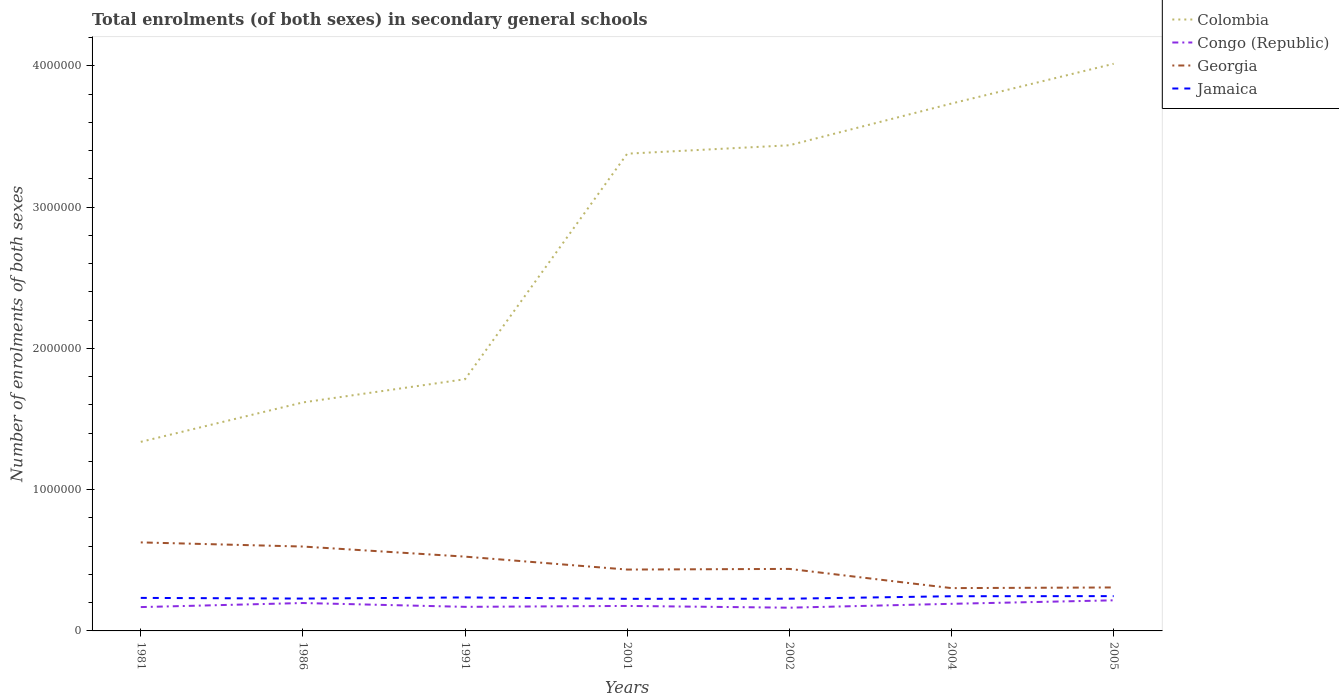Does the line corresponding to Congo (Republic) intersect with the line corresponding to Colombia?
Give a very brief answer. No. Across all years, what is the maximum number of enrolments in secondary schools in Colombia?
Your answer should be compact. 1.34e+06. What is the total number of enrolments in secondary schools in Congo (Republic) in the graph?
Keep it short and to the point. 4215. What is the difference between the highest and the second highest number of enrolments in secondary schools in Georgia?
Keep it short and to the point. 3.24e+05. How many lines are there?
Offer a very short reply. 4. What is the difference between two consecutive major ticks on the Y-axis?
Give a very brief answer. 1.00e+06. Are the values on the major ticks of Y-axis written in scientific E-notation?
Provide a short and direct response. No. Does the graph contain any zero values?
Ensure brevity in your answer.  No. Where does the legend appear in the graph?
Your answer should be compact. Top right. What is the title of the graph?
Provide a short and direct response. Total enrolments (of both sexes) in secondary general schools. What is the label or title of the X-axis?
Keep it short and to the point. Years. What is the label or title of the Y-axis?
Provide a short and direct response. Number of enrolments of both sexes. What is the Number of enrolments of both sexes in Colombia in 1981?
Offer a terse response. 1.34e+06. What is the Number of enrolments of both sexes in Congo (Republic) in 1981?
Your answer should be compact. 1.69e+05. What is the Number of enrolments of both sexes in Georgia in 1981?
Your response must be concise. 6.27e+05. What is the Number of enrolments of both sexes in Jamaica in 1981?
Provide a short and direct response. 2.34e+05. What is the Number of enrolments of both sexes of Colombia in 1986?
Offer a very short reply. 1.62e+06. What is the Number of enrolments of both sexes of Congo (Republic) in 1986?
Provide a short and direct response. 1.97e+05. What is the Number of enrolments of both sexes of Georgia in 1986?
Make the answer very short. 5.97e+05. What is the Number of enrolments of both sexes in Jamaica in 1986?
Offer a very short reply. 2.29e+05. What is the Number of enrolments of both sexes of Colombia in 1991?
Your response must be concise. 1.78e+06. What is the Number of enrolments of both sexes of Congo (Republic) in 1991?
Make the answer very short. 1.70e+05. What is the Number of enrolments of both sexes of Georgia in 1991?
Your answer should be very brief. 5.26e+05. What is the Number of enrolments of both sexes in Jamaica in 1991?
Your response must be concise. 2.37e+05. What is the Number of enrolments of both sexes in Colombia in 2001?
Provide a short and direct response. 3.38e+06. What is the Number of enrolments of both sexes of Congo (Republic) in 2001?
Your response must be concise. 1.77e+05. What is the Number of enrolments of both sexes of Georgia in 2001?
Offer a very short reply. 4.34e+05. What is the Number of enrolments of both sexes of Jamaica in 2001?
Provide a short and direct response. 2.27e+05. What is the Number of enrolments of both sexes in Colombia in 2002?
Keep it short and to the point. 3.44e+06. What is the Number of enrolments of both sexes in Congo (Republic) in 2002?
Provide a short and direct response. 1.65e+05. What is the Number of enrolments of both sexes of Georgia in 2002?
Keep it short and to the point. 4.39e+05. What is the Number of enrolments of both sexes in Jamaica in 2002?
Offer a very short reply. 2.28e+05. What is the Number of enrolments of both sexes in Colombia in 2004?
Provide a succinct answer. 3.73e+06. What is the Number of enrolments of both sexes in Congo (Republic) in 2004?
Offer a terse response. 1.92e+05. What is the Number of enrolments of both sexes in Georgia in 2004?
Offer a terse response. 3.03e+05. What is the Number of enrolments of both sexes in Jamaica in 2004?
Provide a succinct answer. 2.46e+05. What is the Number of enrolments of both sexes in Colombia in 2005?
Your answer should be very brief. 4.01e+06. What is the Number of enrolments of both sexes in Congo (Republic) in 2005?
Give a very brief answer. 2.17e+05. What is the Number of enrolments of both sexes in Georgia in 2005?
Make the answer very short. 3.08e+05. What is the Number of enrolments of both sexes in Jamaica in 2005?
Provide a succinct answer. 2.46e+05. Across all years, what is the maximum Number of enrolments of both sexes of Colombia?
Your answer should be very brief. 4.01e+06. Across all years, what is the maximum Number of enrolments of both sexes in Congo (Republic)?
Keep it short and to the point. 2.17e+05. Across all years, what is the maximum Number of enrolments of both sexes in Georgia?
Your answer should be very brief. 6.27e+05. Across all years, what is the maximum Number of enrolments of both sexes in Jamaica?
Your answer should be very brief. 2.46e+05. Across all years, what is the minimum Number of enrolments of both sexes of Colombia?
Your answer should be compact. 1.34e+06. Across all years, what is the minimum Number of enrolments of both sexes in Congo (Republic)?
Make the answer very short. 1.65e+05. Across all years, what is the minimum Number of enrolments of both sexes in Georgia?
Give a very brief answer. 3.03e+05. Across all years, what is the minimum Number of enrolments of both sexes of Jamaica?
Give a very brief answer. 2.27e+05. What is the total Number of enrolments of both sexes in Colombia in the graph?
Keep it short and to the point. 1.93e+07. What is the total Number of enrolments of both sexes of Congo (Republic) in the graph?
Offer a terse response. 1.29e+06. What is the total Number of enrolments of both sexes of Georgia in the graph?
Offer a very short reply. 3.23e+06. What is the total Number of enrolments of both sexes of Jamaica in the graph?
Your response must be concise. 1.65e+06. What is the difference between the Number of enrolments of both sexes of Colombia in 1981 and that in 1986?
Ensure brevity in your answer.  -2.79e+05. What is the difference between the Number of enrolments of both sexes of Congo (Republic) in 1981 and that in 1986?
Ensure brevity in your answer.  -2.88e+04. What is the difference between the Number of enrolments of both sexes in Georgia in 1981 and that in 1986?
Make the answer very short. 2.93e+04. What is the difference between the Number of enrolments of both sexes of Jamaica in 1981 and that in 1986?
Ensure brevity in your answer.  4700. What is the difference between the Number of enrolments of both sexes in Colombia in 1981 and that in 1991?
Provide a short and direct response. -4.43e+05. What is the difference between the Number of enrolments of both sexes in Congo (Republic) in 1981 and that in 1991?
Offer a very short reply. -1691. What is the difference between the Number of enrolments of both sexes in Georgia in 1981 and that in 1991?
Provide a succinct answer. 1.01e+05. What is the difference between the Number of enrolments of both sexes of Jamaica in 1981 and that in 1991?
Keep it short and to the point. -3277. What is the difference between the Number of enrolments of both sexes in Colombia in 1981 and that in 2001?
Make the answer very short. -2.04e+06. What is the difference between the Number of enrolments of both sexes of Congo (Republic) in 1981 and that in 2001?
Give a very brief answer. -8139. What is the difference between the Number of enrolments of both sexes of Georgia in 1981 and that in 2001?
Your answer should be very brief. 1.92e+05. What is the difference between the Number of enrolments of both sexes of Jamaica in 1981 and that in 2001?
Offer a very short reply. 6518. What is the difference between the Number of enrolments of both sexes in Colombia in 1981 and that in 2002?
Make the answer very short. -2.10e+06. What is the difference between the Number of enrolments of both sexes of Congo (Republic) in 1981 and that in 2002?
Give a very brief answer. 4215. What is the difference between the Number of enrolments of both sexes of Georgia in 1981 and that in 2002?
Give a very brief answer. 1.88e+05. What is the difference between the Number of enrolments of both sexes in Jamaica in 1981 and that in 2002?
Make the answer very short. 5789. What is the difference between the Number of enrolments of both sexes in Colombia in 1981 and that in 2004?
Keep it short and to the point. -2.39e+06. What is the difference between the Number of enrolments of both sexes in Congo (Republic) in 1981 and that in 2004?
Ensure brevity in your answer.  -2.31e+04. What is the difference between the Number of enrolments of both sexes of Georgia in 1981 and that in 2004?
Your answer should be very brief. 3.24e+05. What is the difference between the Number of enrolments of both sexes of Jamaica in 1981 and that in 2004?
Your answer should be very brief. -1.18e+04. What is the difference between the Number of enrolments of both sexes in Colombia in 1981 and that in 2005?
Offer a very short reply. -2.68e+06. What is the difference between the Number of enrolments of both sexes in Congo (Republic) in 1981 and that in 2005?
Make the answer very short. -4.79e+04. What is the difference between the Number of enrolments of both sexes of Georgia in 1981 and that in 2005?
Ensure brevity in your answer.  3.19e+05. What is the difference between the Number of enrolments of both sexes in Jamaica in 1981 and that in 2005?
Offer a terse response. -1.26e+04. What is the difference between the Number of enrolments of both sexes of Colombia in 1986 and that in 1991?
Offer a terse response. -1.64e+05. What is the difference between the Number of enrolments of both sexes in Congo (Republic) in 1986 and that in 1991?
Offer a terse response. 2.71e+04. What is the difference between the Number of enrolments of both sexes of Georgia in 1986 and that in 1991?
Ensure brevity in your answer.  7.14e+04. What is the difference between the Number of enrolments of both sexes in Jamaica in 1986 and that in 1991?
Keep it short and to the point. -7977. What is the difference between the Number of enrolments of both sexes in Colombia in 1986 and that in 2001?
Provide a succinct answer. -1.76e+06. What is the difference between the Number of enrolments of both sexes in Congo (Republic) in 1986 and that in 2001?
Your answer should be very brief. 2.06e+04. What is the difference between the Number of enrolments of both sexes in Georgia in 1986 and that in 2001?
Ensure brevity in your answer.  1.63e+05. What is the difference between the Number of enrolments of both sexes in Jamaica in 1986 and that in 2001?
Make the answer very short. 1818. What is the difference between the Number of enrolments of both sexes of Colombia in 1986 and that in 2002?
Your response must be concise. -1.82e+06. What is the difference between the Number of enrolments of both sexes of Congo (Republic) in 1986 and that in 2002?
Your response must be concise. 3.30e+04. What is the difference between the Number of enrolments of both sexes of Georgia in 1986 and that in 2002?
Provide a succinct answer. 1.58e+05. What is the difference between the Number of enrolments of both sexes of Jamaica in 1986 and that in 2002?
Your answer should be very brief. 1089. What is the difference between the Number of enrolments of both sexes of Colombia in 1986 and that in 2004?
Keep it short and to the point. -2.12e+06. What is the difference between the Number of enrolments of both sexes of Congo (Republic) in 1986 and that in 2004?
Provide a succinct answer. 5634. What is the difference between the Number of enrolments of both sexes in Georgia in 1986 and that in 2004?
Your answer should be compact. 2.94e+05. What is the difference between the Number of enrolments of both sexes in Jamaica in 1986 and that in 2004?
Ensure brevity in your answer.  -1.65e+04. What is the difference between the Number of enrolments of both sexes in Colombia in 1986 and that in 2005?
Your answer should be compact. -2.40e+06. What is the difference between the Number of enrolments of both sexes in Congo (Republic) in 1986 and that in 2005?
Your response must be concise. -1.91e+04. What is the difference between the Number of enrolments of both sexes in Georgia in 1986 and that in 2005?
Your response must be concise. 2.90e+05. What is the difference between the Number of enrolments of both sexes in Jamaica in 1986 and that in 2005?
Keep it short and to the point. -1.73e+04. What is the difference between the Number of enrolments of both sexes in Colombia in 1991 and that in 2001?
Offer a very short reply. -1.60e+06. What is the difference between the Number of enrolments of both sexes in Congo (Republic) in 1991 and that in 2001?
Provide a succinct answer. -6448. What is the difference between the Number of enrolments of both sexes of Georgia in 1991 and that in 2001?
Make the answer very short. 9.15e+04. What is the difference between the Number of enrolments of both sexes in Jamaica in 1991 and that in 2001?
Your answer should be compact. 9795. What is the difference between the Number of enrolments of both sexes of Colombia in 1991 and that in 2002?
Provide a succinct answer. -1.66e+06. What is the difference between the Number of enrolments of both sexes in Congo (Republic) in 1991 and that in 2002?
Ensure brevity in your answer.  5906. What is the difference between the Number of enrolments of both sexes in Georgia in 1991 and that in 2002?
Your response must be concise. 8.68e+04. What is the difference between the Number of enrolments of both sexes in Jamaica in 1991 and that in 2002?
Your answer should be compact. 9066. What is the difference between the Number of enrolments of both sexes in Colombia in 1991 and that in 2004?
Your answer should be very brief. -1.95e+06. What is the difference between the Number of enrolments of both sexes of Congo (Republic) in 1991 and that in 2004?
Ensure brevity in your answer.  -2.14e+04. What is the difference between the Number of enrolments of both sexes in Georgia in 1991 and that in 2004?
Give a very brief answer. 2.23e+05. What is the difference between the Number of enrolments of both sexes in Jamaica in 1991 and that in 2004?
Ensure brevity in your answer.  -8533. What is the difference between the Number of enrolments of both sexes in Colombia in 1991 and that in 2005?
Your answer should be very brief. -2.23e+06. What is the difference between the Number of enrolments of both sexes of Congo (Republic) in 1991 and that in 2005?
Give a very brief answer. -4.62e+04. What is the difference between the Number of enrolments of both sexes of Georgia in 1991 and that in 2005?
Your answer should be very brief. 2.18e+05. What is the difference between the Number of enrolments of both sexes of Jamaica in 1991 and that in 2005?
Make the answer very short. -9332. What is the difference between the Number of enrolments of both sexes of Colombia in 2001 and that in 2002?
Provide a succinct answer. -5.95e+04. What is the difference between the Number of enrolments of both sexes in Congo (Republic) in 2001 and that in 2002?
Your response must be concise. 1.24e+04. What is the difference between the Number of enrolments of both sexes of Georgia in 2001 and that in 2002?
Ensure brevity in your answer.  -4670. What is the difference between the Number of enrolments of both sexes of Jamaica in 2001 and that in 2002?
Your response must be concise. -729. What is the difference between the Number of enrolments of both sexes of Colombia in 2001 and that in 2004?
Provide a short and direct response. -3.55e+05. What is the difference between the Number of enrolments of both sexes in Congo (Republic) in 2001 and that in 2004?
Give a very brief answer. -1.50e+04. What is the difference between the Number of enrolments of both sexes of Georgia in 2001 and that in 2004?
Ensure brevity in your answer.  1.31e+05. What is the difference between the Number of enrolments of both sexes in Jamaica in 2001 and that in 2004?
Make the answer very short. -1.83e+04. What is the difference between the Number of enrolments of both sexes in Colombia in 2001 and that in 2005?
Offer a very short reply. -6.36e+05. What is the difference between the Number of enrolments of both sexes of Congo (Republic) in 2001 and that in 2005?
Give a very brief answer. -3.98e+04. What is the difference between the Number of enrolments of both sexes of Georgia in 2001 and that in 2005?
Offer a terse response. 1.27e+05. What is the difference between the Number of enrolments of both sexes in Jamaica in 2001 and that in 2005?
Your answer should be very brief. -1.91e+04. What is the difference between the Number of enrolments of both sexes in Colombia in 2002 and that in 2004?
Your answer should be compact. -2.95e+05. What is the difference between the Number of enrolments of both sexes in Congo (Republic) in 2002 and that in 2004?
Your answer should be compact. -2.74e+04. What is the difference between the Number of enrolments of both sexes of Georgia in 2002 and that in 2004?
Your response must be concise. 1.36e+05. What is the difference between the Number of enrolments of both sexes of Jamaica in 2002 and that in 2004?
Keep it short and to the point. -1.76e+04. What is the difference between the Number of enrolments of both sexes in Colombia in 2002 and that in 2005?
Provide a short and direct response. -5.77e+05. What is the difference between the Number of enrolments of both sexes of Congo (Republic) in 2002 and that in 2005?
Make the answer very short. -5.21e+04. What is the difference between the Number of enrolments of both sexes of Georgia in 2002 and that in 2005?
Offer a terse response. 1.31e+05. What is the difference between the Number of enrolments of both sexes in Jamaica in 2002 and that in 2005?
Your answer should be compact. -1.84e+04. What is the difference between the Number of enrolments of both sexes of Colombia in 2004 and that in 2005?
Provide a short and direct response. -2.81e+05. What is the difference between the Number of enrolments of both sexes of Congo (Republic) in 2004 and that in 2005?
Your answer should be compact. -2.48e+04. What is the difference between the Number of enrolments of both sexes in Georgia in 2004 and that in 2005?
Offer a very short reply. -4616. What is the difference between the Number of enrolments of both sexes of Jamaica in 2004 and that in 2005?
Provide a succinct answer. -799. What is the difference between the Number of enrolments of both sexes in Colombia in 1981 and the Number of enrolments of both sexes in Congo (Republic) in 1986?
Ensure brevity in your answer.  1.14e+06. What is the difference between the Number of enrolments of both sexes in Colombia in 1981 and the Number of enrolments of both sexes in Georgia in 1986?
Make the answer very short. 7.41e+05. What is the difference between the Number of enrolments of both sexes in Colombia in 1981 and the Number of enrolments of both sexes in Jamaica in 1986?
Offer a very short reply. 1.11e+06. What is the difference between the Number of enrolments of both sexes of Congo (Republic) in 1981 and the Number of enrolments of both sexes of Georgia in 1986?
Offer a very short reply. -4.29e+05. What is the difference between the Number of enrolments of both sexes of Congo (Republic) in 1981 and the Number of enrolments of both sexes of Jamaica in 1986?
Make the answer very short. -6.03e+04. What is the difference between the Number of enrolments of both sexes in Georgia in 1981 and the Number of enrolments of both sexes in Jamaica in 1986?
Give a very brief answer. 3.98e+05. What is the difference between the Number of enrolments of both sexes in Colombia in 1981 and the Number of enrolments of both sexes in Congo (Republic) in 1991?
Make the answer very short. 1.17e+06. What is the difference between the Number of enrolments of both sexes of Colombia in 1981 and the Number of enrolments of both sexes of Georgia in 1991?
Keep it short and to the point. 8.12e+05. What is the difference between the Number of enrolments of both sexes in Colombia in 1981 and the Number of enrolments of both sexes in Jamaica in 1991?
Offer a terse response. 1.10e+06. What is the difference between the Number of enrolments of both sexes in Congo (Republic) in 1981 and the Number of enrolments of both sexes in Georgia in 1991?
Keep it short and to the point. -3.57e+05. What is the difference between the Number of enrolments of both sexes of Congo (Republic) in 1981 and the Number of enrolments of both sexes of Jamaica in 1991?
Keep it short and to the point. -6.83e+04. What is the difference between the Number of enrolments of both sexes in Georgia in 1981 and the Number of enrolments of both sexes in Jamaica in 1991?
Keep it short and to the point. 3.90e+05. What is the difference between the Number of enrolments of both sexes in Colombia in 1981 and the Number of enrolments of both sexes in Congo (Republic) in 2001?
Offer a terse response. 1.16e+06. What is the difference between the Number of enrolments of both sexes of Colombia in 1981 and the Number of enrolments of both sexes of Georgia in 2001?
Offer a terse response. 9.04e+05. What is the difference between the Number of enrolments of both sexes of Colombia in 1981 and the Number of enrolments of both sexes of Jamaica in 2001?
Provide a short and direct response. 1.11e+06. What is the difference between the Number of enrolments of both sexes in Congo (Republic) in 1981 and the Number of enrolments of both sexes in Georgia in 2001?
Provide a short and direct response. -2.66e+05. What is the difference between the Number of enrolments of both sexes of Congo (Republic) in 1981 and the Number of enrolments of both sexes of Jamaica in 2001?
Your answer should be very brief. -5.85e+04. What is the difference between the Number of enrolments of both sexes of Georgia in 1981 and the Number of enrolments of both sexes of Jamaica in 2001?
Your response must be concise. 3.99e+05. What is the difference between the Number of enrolments of both sexes in Colombia in 1981 and the Number of enrolments of both sexes in Congo (Republic) in 2002?
Provide a short and direct response. 1.17e+06. What is the difference between the Number of enrolments of both sexes of Colombia in 1981 and the Number of enrolments of both sexes of Georgia in 2002?
Offer a terse response. 8.99e+05. What is the difference between the Number of enrolments of both sexes in Colombia in 1981 and the Number of enrolments of both sexes in Jamaica in 2002?
Provide a succinct answer. 1.11e+06. What is the difference between the Number of enrolments of both sexes of Congo (Republic) in 1981 and the Number of enrolments of both sexes of Georgia in 2002?
Offer a terse response. -2.70e+05. What is the difference between the Number of enrolments of both sexes of Congo (Republic) in 1981 and the Number of enrolments of both sexes of Jamaica in 2002?
Your answer should be very brief. -5.92e+04. What is the difference between the Number of enrolments of both sexes in Georgia in 1981 and the Number of enrolments of both sexes in Jamaica in 2002?
Give a very brief answer. 3.99e+05. What is the difference between the Number of enrolments of both sexes in Colombia in 1981 and the Number of enrolments of both sexes in Congo (Republic) in 2004?
Give a very brief answer. 1.15e+06. What is the difference between the Number of enrolments of both sexes of Colombia in 1981 and the Number of enrolments of both sexes of Georgia in 2004?
Your answer should be compact. 1.04e+06. What is the difference between the Number of enrolments of both sexes of Colombia in 1981 and the Number of enrolments of both sexes of Jamaica in 2004?
Offer a very short reply. 1.09e+06. What is the difference between the Number of enrolments of both sexes of Congo (Republic) in 1981 and the Number of enrolments of both sexes of Georgia in 2004?
Give a very brief answer. -1.34e+05. What is the difference between the Number of enrolments of both sexes in Congo (Republic) in 1981 and the Number of enrolments of both sexes in Jamaica in 2004?
Give a very brief answer. -7.68e+04. What is the difference between the Number of enrolments of both sexes of Georgia in 1981 and the Number of enrolments of both sexes of Jamaica in 2004?
Your response must be concise. 3.81e+05. What is the difference between the Number of enrolments of both sexes of Colombia in 1981 and the Number of enrolments of both sexes of Congo (Republic) in 2005?
Your answer should be very brief. 1.12e+06. What is the difference between the Number of enrolments of both sexes of Colombia in 1981 and the Number of enrolments of both sexes of Georgia in 2005?
Make the answer very short. 1.03e+06. What is the difference between the Number of enrolments of both sexes in Colombia in 1981 and the Number of enrolments of both sexes in Jamaica in 2005?
Offer a very short reply. 1.09e+06. What is the difference between the Number of enrolments of both sexes of Congo (Republic) in 1981 and the Number of enrolments of both sexes of Georgia in 2005?
Make the answer very short. -1.39e+05. What is the difference between the Number of enrolments of both sexes of Congo (Republic) in 1981 and the Number of enrolments of both sexes of Jamaica in 2005?
Provide a short and direct response. -7.76e+04. What is the difference between the Number of enrolments of both sexes of Georgia in 1981 and the Number of enrolments of both sexes of Jamaica in 2005?
Keep it short and to the point. 3.80e+05. What is the difference between the Number of enrolments of both sexes in Colombia in 1986 and the Number of enrolments of both sexes in Congo (Republic) in 1991?
Ensure brevity in your answer.  1.45e+06. What is the difference between the Number of enrolments of both sexes in Colombia in 1986 and the Number of enrolments of both sexes in Georgia in 1991?
Offer a terse response. 1.09e+06. What is the difference between the Number of enrolments of both sexes of Colombia in 1986 and the Number of enrolments of both sexes of Jamaica in 1991?
Offer a very short reply. 1.38e+06. What is the difference between the Number of enrolments of both sexes of Congo (Republic) in 1986 and the Number of enrolments of both sexes of Georgia in 1991?
Make the answer very short. -3.28e+05. What is the difference between the Number of enrolments of both sexes of Congo (Republic) in 1986 and the Number of enrolments of both sexes of Jamaica in 1991?
Your answer should be very brief. -3.95e+04. What is the difference between the Number of enrolments of both sexes in Georgia in 1986 and the Number of enrolments of both sexes in Jamaica in 1991?
Provide a short and direct response. 3.60e+05. What is the difference between the Number of enrolments of both sexes in Colombia in 1986 and the Number of enrolments of both sexes in Congo (Republic) in 2001?
Offer a very short reply. 1.44e+06. What is the difference between the Number of enrolments of both sexes in Colombia in 1986 and the Number of enrolments of both sexes in Georgia in 2001?
Your answer should be compact. 1.18e+06. What is the difference between the Number of enrolments of both sexes of Colombia in 1986 and the Number of enrolments of both sexes of Jamaica in 2001?
Offer a very short reply. 1.39e+06. What is the difference between the Number of enrolments of both sexes in Congo (Republic) in 1986 and the Number of enrolments of both sexes in Georgia in 2001?
Ensure brevity in your answer.  -2.37e+05. What is the difference between the Number of enrolments of both sexes of Congo (Republic) in 1986 and the Number of enrolments of both sexes of Jamaica in 2001?
Your answer should be compact. -2.97e+04. What is the difference between the Number of enrolments of both sexes in Georgia in 1986 and the Number of enrolments of both sexes in Jamaica in 2001?
Provide a short and direct response. 3.70e+05. What is the difference between the Number of enrolments of both sexes of Colombia in 1986 and the Number of enrolments of both sexes of Congo (Republic) in 2002?
Offer a very short reply. 1.45e+06. What is the difference between the Number of enrolments of both sexes in Colombia in 1986 and the Number of enrolments of both sexes in Georgia in 2002?
Provide a short and direct response. 1.18e+06. What is the difference between the Number of enrolments of both sexes in Colombia in 1986 and the Number of enrolments of both sexes in Jamaica in 2002?
Give a very brief answer. 1.39e+06. What is the difference between the Number of enrolments of both sexes of Congo (Republic) in 1986 and the Number of enrolments of both sexes of Georgia in 2002?
Provide a short and direct response. -2.41e+05. What is the difference between the Number of enrolments of both sexes in Congo (Republic) in 1986 and the Number of enrolments of both sexes in Jamaica in 2002?
Provide a succinct answer. -3.04e+04. What is the difference between the Number of enrolments of both sexes in Georgia in 1986 and the Number of enrolments of both sexes in Jamaica in 2002?
Your response must be concise. 3.69e+05. What is the difference between the Number of enrolments of both sexes of Colombia in 1986 and the Number of enrolments of both sexes of Congo (Republic) in 2004?
Provide a short and direct response. 1.43e+06. What is the difference between the Number of enrolments of both sexes of Colombia in 1986 and the Number of enrolments of both sexes of Georgia in 2004?
Offer a terse response. 1.31e+06. What is the difference between the Number of enrolments of both sexes in Colombia in 1986 and the Number of enrolments of both sexes in Jamaica in 2004?
Your response must be concise. 1.37e+06. What is the difference between the Number of enrolments of both sexes in Congo (Republic) in 1986 and the Number of enrolments of both sexes in Georgia in 2004?
Your answer should be very brief. -1.06e+05. What is the difference between the Number of enrolments of both sexes of Congo (Republic) in 1986 and the Number of enrolments of both sexes of Jamaica in 2004?
Your answer should be compact. -4.80e+04. What is the difference between the Number of enrolments of both sexes of Georgia in 1986 and the Number of enrolments of both sexes of Jamaica in 2004?
Keep it short and to the point. 3.52e+05. What is the difference between the Number of enrolments of both sexes in Colombia in 1986 and the Number of enrolments of both sexes in Congo (Republic) in 2005?
Give a very brief answer. 1.40e+06. What is the difference between the Number of enrolments of both sexes of Colombia in 1986 and the Number of enrolments of both sexes of Georgia in 2005?
Provide a succinct answer. 1.31e+06. What is the difference between the Number of enrolments of both sexes of Colombia in 1986 and the Number of enrolments of both sexes of Jamaica in 2005?
Your answer should be very brief. 1.37e+06. What is the difference between the Number of enrolments of both sexes of Congo (Republic) in 1986 and the Number of enrolments of both sexes of Georgia in 2005?
Keep it short and to the point. -1.10e+05. What is the difference between the Number of enrolments of both sexes of Congo (Republic) in 1986 and the Number of enrolments of both sexes of Jamaica in 2005?
Keep it short and to the point. -4.88e+04. What is the difference between the Number of enrolments of both sexes of Georgia in 1986 and the Number of enrolments of both sexes of Jamaica in 2005?
Make the answer very short. 3.51e+05. What is the difference between the Number of enrolments of both sexes in Colombia in 1991 and the Number of enrolments of both sexes in Congo (Republic) in 2001?
Your response must be concise. 1.60e+06. What is the difference between the Number of enrolments of both sexes of Colombia in 1991 and the Number of enrolments of both sexes of Georgia in 2001?
Your answer should be compact. 1.35e+06. What is the difference between the Number of enrolments of both sexes in Colombia in 1991 and the Number of enrolments of both sexes in Jamaica in 2001?
Offer a terse response. 1.55e+06. What is the difference between the Number of enrolments of both sexes of Congo (Republic) in 1991 and the Number of enrolments of both sexes of Georgia in 2001?
Provide a short and direct response. -2.64e+05. What is the difference between the Number of enrolments of both sexes in Congo (Republic) in 1991 and the Number of enrolments of both sexes in Jamaica in 2001?
Provide a short and direct response. -5.68e+04. What is the difference between the Number of enrolments of both sexes of Georgia in 1991 and the Number of enrolments of both sexes of Jamaica in 2001?
Provide a succinct answer. 2.99e+05. What is the difference between the Number of enrolments of both sexes of Colombia in 1991 and the Number of enrolments of both sexes of Congo (Republic) in 2002?
Make the answer very short. 1.62e+06. What is the difference between the Number of enrolments of both sexes of Colombia in 1991 and the Number of enrolments of both sexes of Georgia in 2002?
Give a very brief answer. 1.34e+06. What is the difference between the Number of enrolments of both sexes of Colombia in 1991 and the Number of enrolments of both sexes of Jamaica in 2002?
Provide a succinct answer. 1.55e+06. What is the difference between the Number of enrolments of both sexes in Congo (Republic) in 1991 and the Number of enrolments of both sexes in Georgia in 2002?
Your answer should be very brief. -2.69e+05. What is the difference between the Number of enrolments of both sexes of Congo (Republic) in 1991 and the Number of enrolments of both sexes of Jamaica in 2002?
Make the answer very short. -5.75e+04. What is the difference between the Number of enrolments of both sexes in Georgia in 1991 and the Number of enrolments of both sexes in Jamaica in 2002?
Ensure brevity in your answer.  2.98e+05. What is the difference between the Number of enrolments of both sexes of Colombia in 1991 and the Number of enrolments of both sexes of Congo (Republic) in 2004?
Provide a succinct answer. 1.59e+06. What is the difference between the Number of enrolments of both sexes of Colombia in 1991 and the Number of enrolments of both sexes of Georgia in 2004?
Your response must be concise. 1.48e+06. What is the difference between the Number of enrolments of both sexes in Colombia in 1991 and the Number of enrolments of both sexes in Jamaica in 2004?
Your answer should be compact. 1.54e+06. What is the difference between the Number of enrolments of both sexes in Congo (Republic) in 1991 and the Number of enrolments of both sexes in Georgia in 2004?
Your answer should be very brief. -1.33e+05. What is the difference between the Number of enrolments of both sexes of Congo (Republic) in 1991 and the Number of enrolments of both sexes of Jamaica in 2004?
Offer a terse response. -7.51e+04. What is the difference between the Number of enrolments of both sexes in Georgia in 1991 and the Number of enrolments of both sexes in Jamaica in 2004?
Ensure brevity in your answer.  2.80e+05. What is the difference between the Number of enrolments of both sexes in Colombia in 1991 and the Number of enrolments of both sexes in Congo (Republic) in 2005?
Make the answer very short. 1.56e+06. What is the difference between the Number of enrolments of both sexes of Colombia in 1991 and the Number of enrolments of both sexes of Georgia in 2005?
Give a very brief answer. 1.47e+06. What is the difference between the Number of enrolments of both sexes in Colombia in 1991 and the Number of enrolments of both sexes in Jamaica in 2005?
Offer a very short reply. 1.54e+06. What is the difference between the Number of enrolments of both sexes of Congo (Republic) in 1991 and the Number of enrolments of both sexes of Georgia in 2005?
Your answer should be very brief. -1.37e+05. What is the difference between the Number of enrolments of both sexes of Congo (Republic) in 1991 and the Number of enrolments of both sexes of Jamaica in 2005?
Ensure brevity in your answer.  -7.59e+04. What is the difference between the Number of enrolments of both sexes in Georgia in 1991 and the Number of enrolments of both sexes in Jamaica in 2005?
Offer a very short reply. 2.79e+05. What is the difference between the Number of enrolments of both sexes in Colombia in 2001 and the Number of enrolments of both sexes in Congo (Republic) in 2002?
Keep it short and to the point. 3.21e+06. What is the difference between the Number of enrolments of both sexes in Colombia in 2001 and the Number of enrolments of both sexes in Georgia in 2002?
Your answer should be very brief. 2.94e+06. What is the difference between the Number of enrolments of both sexes in Colombia in 2001 and the Number of enrolments of both sexes in Jamaica in 2002?
Keep it short and to the point. 3.15e+06. What is the difference between the Number of enrolments of both sexes of Congo (Republic) in 2001 and the Number of enrolments of both sexes of Georgia in 2002?
Provide a short and direct response. -2.62e+05. What is the difference between the Number of enrolments of both sexes in Congo (Republic) in 2001 and the Number of enrolments of both sexes in Jamaica in 2002?
Make the answer very short. -5.11e+04. What is the difference between the Number of enrolments of both sexes in Georgia in 2001 and the Number of enrolments of both sexes in Jamaica in 2002?
Offer a very short reply. 2.06e+05. What is the difference between the Number of enrolments of both sexes in Colombia in 2001 and the Number of enrolments of both sexes in Congo (Republic) in 2004?
Make the answer very short. 3.19e+06. What is the difference between the Number of enrolments of both sexes in Colombia in 2001 and the Number of enrolments of both sexes in Georgia in 2004?
Keep it short and to the point. 3.07e+06. What is the difference between the Number of enrolments of both sexes in Colombia in 2001 and the Number of enrolments of both sexes in Jamaica in 2004?
Your answer should be compact. 3.13e+06. What is the difference between the Number of enrolments of both sexes of Congo (Republic) in 2001 and the Number of enrolments of both sexes of Georgia in 2004?
Give a very brief answer. -1.26e+05. What is the difference between the Number of enrolments of both sexes in Congo (Republic) in 2001 and the Number of enrolments of both sexes in Jamaica in 2004?
Offer a terse response. -6.87e+04. What is the difference between the Number of enrolments of both sexes of Georgia in 2001 and the Number of enrolments of both sexes of Jamaica in 2004?
Offer a very short reply. 1.89e+05. What is the difference between the Number of enrolments of both sexes in Colombia in 2001 and the Number of enrolments of both sexes in Congo (Republic) in 2005?
Keep it short and to the point. 3.16e+06. What is the difference between the Number of enrolments of both sexes in Colombia in 2001 and the Number of enrolments of both sexes in Georgia in 2005?
Provide a succinct answer. 3.07e+06. What is the difference between the Number of enrolments of both sexes of Colombia in 2001 and the Number of enrolments of both sexes of Jamaica in 2005?
Give a very brief answer. 3.13e+06. What is the difference between the Number of enrolments of both sexes of Congo (Republic) in 2001 and the Number of enrolments of both sexes of Georgia in 2005?
Make the answer very short. -1.31e+05. What is the difference between the Number of enrolments of both sexes in Congo (Republic) in 2001 and the Number of enrolments of both sexes in Jamaica in 2005?
Keep it short and to the point. -6.95e+04. What is the difference between the Number of enrolments of both sexes in Georgia in 2001 and the Number of enrolments of both sexes in Jamaica in 2005?
Your answer should be compact. 1.88e+05. What is the difference between the Number of enrolments of both sexes of Colombia in 2002 and the Number of enrolments of both sexes of Congo (Republic) in 2004?
Keep it short and to the point. 3.25e+06. What is the difference between the Number of enrolments of both sexes of Colombia in 2002 and the Number of enrolments of both sexes of Georgia in 2004?
Your answer should be compact. 3.13e+06. What is the difference between the Number of enrolments of both sexes in Colombia in 2002 and the Number of enrolments of both sexes in Jamaica in 2004?
Keep it short and to the point. 3.19e+06. What is the difference between the Number of enrolments of both sexes of Congo (Republic) in 2002 and the Number of enrolments of both sexes of Georgia in 2004?
Provide a short and direct response. -1.39e+05. What is the difference between the Number of enrolments of both sexes in Congo (Republic) in 2002 and the Number of enrolments of both sexes in Jamaica in 2004?
Make the answer very short. -8.10e+04. What is the difference between the Number of enrolments of both sexes in Georgia in 2002 and the Number of enrolments of both sexes in Jamaica in 2004?
Provide a short and direct response. 1.93e+05. What is the difference between the Number of enrolments of both sexes of Colombia in 2002 and the Number of enrolments of both sexes of Congo (Republic) in 2005?
Offer a terse response. 3.22e+06. What is the difference between the Number of enrolments of both sexes of Colombia in 2002 and the Number of enrolments of both sexes of Georgia in 2005?
Make the answer very short. 3.13e+06. What is the difference between the Number of enrolments of both sexes of Colombia in 2002 and the Number of enrolments of both sexes of Jamaica in 2005?
Make the answer very short. 3.19e+06. What is the difference between the Number of enrolments of both sexes of Congo (Republic) in 2002 and the Number of enrolments of both sexes of Georgia in 2005?
Give a very brief answer. -1.43e+05. What is the difference between the Number of enrolments of both sexes in Congo (Republic) in 2002 and the Number of enrolments of both sexes in Jamaica in 2005?
Offer a very short reply. -8.18e+04. What is the difference between the Number of enrolments of both sexes of Georgia in 2002 and the Number of enrolments of both sexes of Jamaica in 2005?
Ensure brevity in your answer.  1.93e+05. What is the difference between the Number of enrolments of both sexes of Colombia in 2004 and the Number of enrolments of both sexes of Congo (Republic) in 2005?
Ensure brevity in your answer.  3.52e+06. What is the difference between the Number of enrolments of both sexes of Colombia in 2004 and the Number of enrolments of both sexes of Georgia in 2005?
Provide a succinct answer. 3.43e+06. What is the difference between the Number of enrolments of both sexes in Colombia in 2004 and the Number of enrolments of both sexes in Jamaica in 2005?
Offer a terse response. 3.49e+06. What is the difference between the Number of enrolments of both sexes of Congo (Republic) in 2004 and the Number of enrolments of both sexes of Georgia in 2005?
Provide a succinct answer. -1.16e+05. What is the difference between the Number of enrolments of both sexes of Congo (Republic) in 2004 and the Number of enrolments of both sexes of Jamaica in 2005?
Your response must be concise. -5.45e+04. What is the difference between the Number of enrolments of both sexes of Georgia in 2004 and the Number of enrolments of both sexes of Jamaica in 2005?
Offer a very short reply. 5.67e+04. What is the average Number of enrolments of both sexes of Colombia per year?
Your answer should be very brief. 2.76e+06. What is the average Number of enrolments of both sexes of Congo (Republic) per year?
Offer a terse response. 1.84e+05. What is the average Number of enrolments of both sexes in Georgia per year?
Give a very brief answer. 4.62e+05. What is the average Number of enrolments of both sexes in Jamaica per year?
Offer a terse response. 2.35e+05. In the year 1981, what is the difference between the Number of enrolments of both sexes in Colombia and Number of enrolments of both sexes in Congo (Republic)?
Your answer should be compact. 1.17e+06. In the year 1981, what is the difference between the Number of enrolments of both sexes in Colombia and Number of enrolments of both sexes in Georgia?
Provide a short and direct response. 7.12e+05. In the year 1981, what is the difference between the Number of enrolments of both sexes of Colombia and Number of enrolments of both sexes of Jamaica?
Offer a very short reply. 1.10e+06. In the year 1981, what is the difference between the Number of enrolments of both sexes in Congo (Republic) and Number of enrolments of both sexes in Georgia?
Provide a short and direct response. -4.58e+05. In the year 1981, what is the difference between the Number of enrolments of both sexes in Congo (Republic) and Number of enrolments of both sexes in Jamaica?
Your response must be concise. -6.50e+04. In the year 1981, what is the difference between the Number of enrolments of both sexes of Georgia and Number of enrolments of both sexes of Jamaica?
Offer a terse response. 3.93e+05. In the year 1986, what is the difference between the Number of enrolments of both sexes of Colombia and Number of enrolments of both sexes of Congo (Republic)?
Give a very brief answer. 1.42e+06. In the year 1986, what is the difference between the Number of enrolments of both sexes of Colombia and Number of enrolments of both sexes of Georgia?
Your answer should be compact. 1.02e+06. In the year 1986, what is the difference between the Number of enrolments of both sexes in Colombia and Number of enrolments of both sexes in Jamaica?
Your response must be concise. 1.39e+06. In the year 1986, what is the difference between the Number of enrolments of both sexes of Congo (Republic) and Number of enrolments of both sexes of Georgia?
Offer a terse response. -4.00e+05. In the year 1986, what is the difference between the Number of enrolments of both sexes of Congo (Republic) and Number of enrolments of both sexes of Jamaica?
Make the answer very short. -3.15e+04. In the year 1986, what is the difference between the Number of enrolments of both sexes in Georgia and Number of enrolments of both sexes in Jamaica?
Your answer should be very brief. 3.68e+05. In the year 1991, what is the difference between the Number of enrolments of both sexes of Colombia and Number of enrolments of both sexes of Congo (Republic)?
Keep it short and to the point. 1.61e+06. In the year 1991, what is the difference between the Number of enrolments of both sexes in Colombia and Number of enrolments of both sexes in Georgia?
Ensure brevity in your answer.  1.26e+06. In the year 1991, what is the difference between the Number of enrolments of both sexes of Colombia and Number of enrolments of both sexes of Jamaica?
Make the answer very short. 1.54e+06. In the year 1991, what is the difference between the Number of enrolments of both sexes in Congo (Republic) and Number of enrolments of both sexes in Georgia?
Your answer should be very brief. -3.55e+05. In the year 1991, what is the difference between the Number of enrolments of both sexes of Congo (Republic) and Number of enrolments of both sexes of Jamaica?
Your response must be concise. -6.66e+04. In the year 1991, what is the difference between the Number of enrolments of both sexes in Georgia and Number of enrolments of both sexes in Jamaica?
Your response must be concise. 2.89e+05. In the year 2001, what is the difference between the Number of enrolments of both sexes in Colombia and Number of enrolments of both sexes in Congo (Republic)?
Provide a succinct answer. 3.20e+06. In the year 2001, what is the difference between the Number of enrolments of both sexes of Colombia and Number of enrolments of both sexes of Georgia?
Offer a very short reply. 2.94e+06. In the year 2001, what is the difference between the Number of enrolments of both sexes of Colombia and Number of enrolments of both sexes of Jamaica?
Your response must be concise. 3.15e+06. In the year 2001, what is the difference between the Number of enrolments of both sexes in Congo (Republic) and Number of enrolments of both sexes in Georgia?
Your response must be concise. -2.57e+05. In the year 2001, what is the difference between the Number of enrolments of both sexes in Congo (Republic) and Number of enrolments of both sexes in Jamaica?
Provide a succinct answer. -5.03e+04. In the year 2001, what is the difference between the Number of enrolments of both sexes of Georgia and Number of enrolments of both sexes of Jamaica?
Provide a succinct answer. 2.07e+05. In the year 2002, what is the difference between the Number of enrolments of both sexes in Colombia and Number of enrolments of both sexes in Congo (Republic)?
Keep it short and to the point. 3.27e+06. In the year 2002, what is the difference between the Number of enrolments of both sexes of Colombia and Number of enrolments of both sexes of Georgia?
Provide a succinct answer. 3.00e+06. In the year 2002, what is the difference between the Number of enrolments of both sexes in Colombia and Number of enrolments of both sexes in Jamaica?
Keep it short and to the point. 3.21e+06. In the year 2002, what is the difference between the Number of enrolments of both sexes of Congo (Republic) and Number of enrolments of both sexes of Georgia?
Provide a short and direct response. -2.74e+05. In the year 2002, what is the difference between the Number of enrolments of both sexes of Congo (Republic) and Number of enrolments of both sexes of Jamaica?
Offer a terse response. -6.34e+04. In the year 2002, what is the difference between the Number of enrolments of both sexes in Georgia and Number of enrolments of both sexes in Jamaica?
Make the answer very short. 2.11e+05. In the year 2004, what is the difference between the Number of enrolments of both sexes of Colombia and Number of enrolments of both sexes of Congo (Republic)?
Ensure brevity in your answer.  3.54e+06. In the year 2004, what is the difference between the Number of enrolments of both sexes of Colombia and Number of enrolments of both sexes of Georgia?
Your answer should be very brief. 3.43e+06. In the year 2004, what is the difference between the Number of enrolments of both sexes of Colombia and Number of enrolments of both sexes of Jamaica?
Your answer should be compact. 3.49e+06. In the year 2004, what is the difference between the Number of enrolments of both sexes in Congo (Republic) and Number of enrolments of both sexes in Georgia?
Ensure brevity in your answer.  -1.11e+05. In the year 2004, what is the difference between the Number of enrolments of both sexes in Congo (Republic) and Number of enrolments of both sexes in Jamaica?
Provide a succinct answer. -5.37e+04. In the year 2004, what is the difference between the Number of enrolments of both sexes of Georgia and Number of enrolments of both sexes of Jamaica?
Offer a very short reply. 5.75e+04. In the year 2005, what is the difference between the Number of enrolments of both sexes of Colombia and Number of enrolments of both sexes of Congo (Republic)?
Keep it short and to the point. 3.80e+06. In the year 2005, what is the difference between the Number of enrolments of both sexes in Colombia and Number of enrolments of both sexes in Georgia?
Provide a succinct answer. 3.71e+06. In the year 2005, what is the difference between the Number of enrolments of both sexes in Colombia and Number of enrolments of both sexes in Jamaica?
Ensure brevity in your answer.  3.77e+06. In the year 2005, what is the difference between the Number of enrolments of both sexes of Congo (Republic) and Number of enrolments of both sexes of Georgia?
Offer a very short reply. -9.10e+04. In the year 2005, what is the difference between the Number of enrolments of both sexes of Congo (Republic) and Number of enrolments of both sexes of Jamaica?
Offer a terse response. -2.97e+04. In the year 2005, what is the difference between the Number of enrolments of both sexes of Georgia and Number of enrolments of both sexes of Jamaica?
Your response must be concise. 6.13e+04. What is the ratio of the Number of enrolments of both sexes of Colombia in 1981 to that in 1986?
Keep it short and to the point. 0.83. What is the ratio of the Number of enrolments of both sexes in Congo (Republic) in 1981 to that in 1986?
Ensure brevity in your answer.  0.85. What is the ratio of the Number of enrolments of both sexes in Georgia in 1981 to that in 1986?
Your response must be concise. 1.05. What is the ratio of the Number of enrolments of both sexes in Jamaica in 1981 to that in 1986?
Offer a terse response. 1.02. What is the ratio of the Number of enrolments of both sexes of Colombia in 1981 to that in 1991?
Offer a very short reply. 0.75. What is the ratio of the Number of enrolments of both sexes in Congo (Republic) in 1981 to that in 1991?
Offer a terse response. 0.99. What is the ratio of the Number of enrolments of both sexes in Georgia in 1981 to that in 1991?
Give a very brief answer. 1.19. What is the ratio of the Number of enrolments of both sexes in Jamaica in 1981 to that in 1991?
Offer a terse response. 0.99. What is the ratio of the Number of enrolments of both sexes of Colombia in 1981 to that in 2001?
Provide a short and direct response. 0.4. What is the ratio of the Number of enrolments of both sexes in Congo (Republic) in 1981 to that in 2001?
Your response must be concise. 0.95. What is the ratio of the Number of enrolments of both sexes of Georgia in 1981 to that in 2001?
Ensure brevity in your answer.  1.44. What is the ratio of the Number of enrolments of both sexes of Jamaica in 1981 to that in 2001?
Your answer should be compact. 1.03. What is the ratio of the Number of enrolments of both sexes in Colombia in 1981 to that in 2002?
Provide a succinct answer. 0.39. What is the ratio of the Number of enrolments of both sexes of Congo (Republic) in 1981 to that in 2002?
Your response must be concise. 1.03. What is the ratio of the Number of enrolments of both sexes in Georgia in 1981 to that in 2002?
Your response must be concise. 1.43. What is the ratio of the Number of enrolments of both sexes of Jamaica in 1981 to that in 2002?
Provide a succinct answer. 1.03. What is the ratio of the Number of enrolments of both sexes of Colombia in 1981 to that in 2004?
Make the answer very short. 0.36. What is the ratio of the Number of enrolments of both sexes of Congo (Republic) in 1981 to that in 2004?
Offer a terse response. 0.88. What is the ratio of the Number of enrolments of both sexes in Georgia in 1981 to that in 2004?
Make the answer very short. 2.07. What is the ratio of the Number of enrolments of both sexes of Jamaica in 1981 to that in 2004?
Ensure brevity in your answer.  0.95. What is the ratio of the Number of enrolments of both sexes in Colombia in 1981 to that in 2005?
Give a very brief answer. 0.33. What is the ratio of the Number of enrolments of both sexes of Congo (Republic) in 1981 to that in 2005?
Ensure brevity in your answer.  0.78. What is the ratio of the Number of enrolments of both sexes in Georgia in 1981 to that in 2005?
Provide a short and direct response. 2.04. What is the ratio of the Number of enrolments of both sexes in Jamaica in 1981 to that in 2005?
Offer a very short reply. 0.95. What is the ratio of the Number of enrolments of both sexes in Colombia in 1986 to that in 1991?
Provide a short and direct response. 0.91. What is the ratio of the Number of enrolments of both sexes in Congo (Republic) in 1986 to that in 1991?
Offer a terse response. 1.16. What is the ratio of the Number of enrolments of both sexes in Georgia in 1986 to that in 1991?
Your response must be concise. 1.14. What is the ratio of the Number of enrolments of both sexes in Jamaica in 1986 to that in 1991?
Make the answer very short. 0.97. What is the ratio of the Number of enrolments of both sexes in Colombia in 1986 to that in 2001?
Provide a succinct answer. 0.48. What is the ratio of the Number of enrolments of both sexes of Congo (Republic) in 1986 to that in 2001?
Offer a terse response. 1.12. What is the ratio of the Number of enrolments of both sexes in Georgia in 1986 to that in 2001?
Offer a terse response. 1.38. What is the ratio of the Number of enrolments of both sexes of Jamaica in 1986 to that in 2001?
Give a very brief answer. 1.01. What is the ratio of the Number of enrolments of both sexes in Colombia in 1986 to that in 2002?
Offer a terse response. 0.47. What is the ratio of the Number of enrolments of both sexes of Congo (Republic) in 1986 to that in 2002?
Keep it short and to the point. 1.2. What is the ratio of the Number of enrolments of both sexes of Georgia in 1986 to that in 2002?
Offer a terse response. 1.36. What is the ratio of the Number of enrolments of both sexes in Jamaica in 1986 to that in 2002?
Your response must be concise. 1. What is the ratio of the Number of enrolments of both sexes in Colombia in 1986 to that in 2004?
Make the answer very short. 0.43. What is the ratio of the Number of enrolments of both sexes of Congo (Republic) in 1986 to that in 2004?
Your answer should be compact. 1.03. What is the ratio of the Number of enrolments of both sexes in Georgia in 1986 to that in 2004?
Keep it short and to the point. 1.97. What is the ratio of the Number of enrolments of both sexes in Jamaica in 1986 to that in 2004?
Your answer should be compact. 0.93. What is the ratio of the Number of enrolments of both sexes in Colombia in 1986 to that in 2005?
Keep it short and to the point. 0.4. What is the ratio of the Number of enrolments of both sexes in Congo (Republic) in 1986 to that in 2005?
Your response must be concise. 0.91. What is the ratio of the Number of enrolments of both sexes in Georgia in 1986 to that in 2005?
Keep it short and to the point. 1.94. What is the ratio of the Number of enrolments of both sexes of Jamaica in 1986 to that in 2005?
Offer a terse response. 0.93. What is the ratio of the Number of enrolments of both sexes in Colombia in 1991 to that in 2001?
Keep it short and to the point. 0.53. What is the ratio of the Number of enrolments of both sexes of Congo (Republic) in 1991 to that in 2001?
Keep it short and to the point. 0.96. What is the ratio of the Number of enrolments of both sexes of Georgia in 1991 to that in 2001?
Your answer should be compact. 1.21. What is the ratio of the Number of enrolments of both sexes of Jamaica in 1991 to that in 2001?
Make the answer very short. 1.04. What is the ratio of the Number of enrolments of both sexes in Colombia in 1991 to that in 2002?
Provide a short and direct response. 0.52. What is the ratio of the Number of enrolments of both sexes of Congo (Republic) in 1991 to that in 2002?
Your answer should be very brief. 1.04. What is the ratio of the Number of enrolments of both sexes of Georgia in 1991 to that in 2002?
Ensure brevity in your answer.  1.2. What is the ratio of the Number of enrolments of both sexes of Jamaica in 1991 to that in 2002?
Provide a succinct answer. 1.04. What is the ratio of the Number of enrolments of both sexes in Colombia in 1991 to that in 2004?
Your response must be concise. 0.48. What is the ratio of the Number of enrolments of both sexes of Congo (Republic) in 1991 to that in 2004?
Provide a succinct answer. 0.89. What is the ratio of the Number of enrolments of both sexes of Georgia in 1991 to that in 2004?
Provide a succinct answer. 1.74. What is the ratio of the Number of enrolments of both sexes of Jamaica in 1991 to that in 2004?
Your response must be concise. 0.97. What is the ratio of the Number of enrolments of both sexes in Colombia in 1991 to that in 2005?
Your answer should be very brief. 0.44. What is the ratio of the Number of enrolments of both sexes in Congo (Republic) in 1991 to that in 2005?
Your answer should be very brief. 0.79. What is the ratio of the Number of enrolments of both sexes in Georgia in 1991 to that in 2005?
Give a very brief answer. 1.71. What is the ratio of the Number of enrolments of both sexes in Jamaica in 1991 to that in 2005?
Make the answer very short. 0.96. What is the ratio of the Number of enrolments of both sexes in Colombia in 2001 to that in 2002?
Provide a short and direct response. 0.98. What is the ratio of the Number of enrolments of both sexes of Congo (Republic) in 2001 to that in 2002?
Make the answer very short. 1.08. What is the ratio of the Number of enrolments of both sexes in Colombia in 2001 to that in 2004?
Give a very brief answer. 0.9. What is the ratio of the Number of enrolments of both sexes in Congo (Republic) in 2001 to that in 2004?
Ensure brevity in your answer.  0.92. What is the ratio of the Number of enrolments of both sexes of Georgia in 2001 to that in 2004?
Your answer should be very brief. 1.43. What is the ratio of the Number of enrolments of both sexes in Jamaica in 2001 to that in 2004?
Provide a succinct answer. 0.93. What is the ratio of the Number of enrolments of both sexes in Colombia in 2001 to that in 2005?
Your response must be concise. 0.84. What is the ratio of the Number of enrolments of both sexes of Congo (Republic) in 2001 to that in 2005?
Provide a succinct answer. 0.82. What is the ratio of the Number of enrolments of both sexes of Georgia in 2001 to that in 2005?
Give a very brief answer. 1.41. What is the ratio of the Number of enrolments of both sexes of Jamaica in 2001 to that in 2005?
Provide a succinct answer. 0.92. What is the ratio of the Number of enrolments of both sexes of Colombia in 2002 to that in 2004?
Give a very brief answer. 0.92. What is the ratio of the Number of enrolments of both sexes in Congo (Republic) in 2002 to that in 2004?
Keep it short and to the point. 0.86. What is the ratio of the Number of enrolments of both sexes of Georgia in 2002 to that in 2004?
Ensure brevity in your answer.  1.45. What is the ratio of the Number of enrolments of both sexes of Jamaica in 2002 to that in 2004?
Make the answer very short. 0.93. What is the ratio of the Number of enrolments of both sexes in Colombia in 2002 to that in 2005?
Your response must be concise. 0.86. What is the ratio of the Number of enrolments of both sexes of Congo (Republic) in 2002 to that in 2005?
Offer a very short reply. 0.76. What is the ratio of the Number of enrolments of both sexes of Georgia in 2002 to that in 2005?
Your answer should be very brief. 1.43. What is the ratio of the Number of enrolments of both sexes of Jamaica in 2002 to that in 2005?
Provide a short and direct response. 0.93. What is the ratio of the Number of enrolments of both sexes in Colombia in 2004 to that in 2005?
Provide a short and direct response. 0.93. What is the ratio of the Number of enrolments of both sexes in Congo (Republic) in 2004 to that in 2005?
Offer a terse response. 0.89. What is the ratio of the Number of enrolments of both sexes of Jamaica in 2004 to that in 2005?
Keep it short and to the point. 1. What is the difference between the highest and the second highest Number of enrolments of both sexes in Colombia?
Provide a succinct answer. 2.81e+05. What is the difference between the highest and the second highest Number of enrolments of both sexes in Congo (Republic)?
Make the answer very short. 1.91e+04. What is the difference between the highest and the second highest Number of enrolments of both sexes of Georgia?
Make the answer very short. 2.93e+04. What is the difference between the highest and the second highest Number of enrolments of both sexes in Jamaica?
Make the answer very short. 799. What is the difference between the highest and the lowest Number of enrolments of both sexes of Colombia?
Ensure brevity in your answer.  2.68e+06. What is the difference between the highest and the lowest Number of enrolments of both sexes in Congo (Republic)?
Make the answer very short. 5.21e+04. What is the difference between the highest and the lowest Number of enrolments of both sexes of Georgia?
Make the answer very short. 3.24e+05. What is the difference between the highest and the lowest Number of enrolments of both sexes of Jamaica?
Your response must be concise. 1.91e+04. 